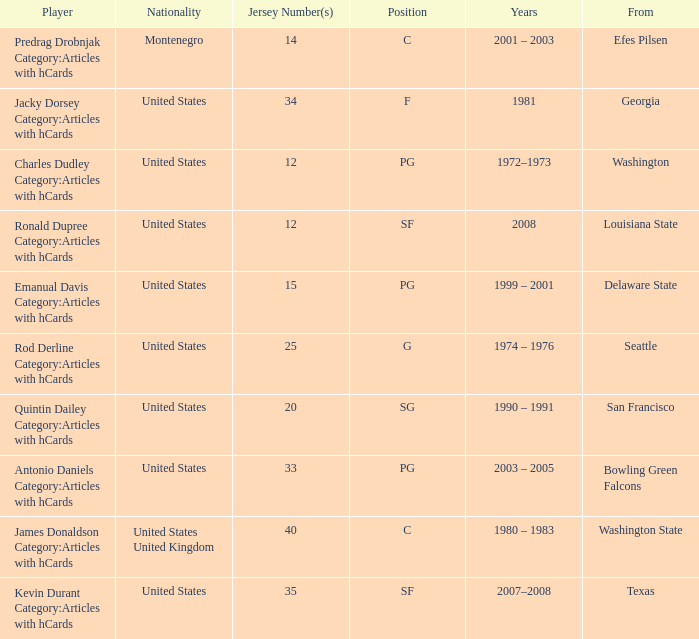From what educational institution did the participant with the 34 jersey number originate? Georgia. Would you be able to parse every entry in this table? {'header': ['Player', 'Nationality', 'Jersey Number(s)', 'Position', 'Years', 'From'], 'rows': [['Predrag Drobnjak Category:Articles with hCards', 'Montenegro', '14', 'C', '2001 – 2003', 'Efes Pilsen'], ['Jacky Dorsey Category:Articles with hCards', 'United States', '34', 'F', '1981', 'Georgia'], ['Charles Dudley Category:Articles with hCards', 'United States', '12', 'PG', '1972–1973', 'Washington'], ['Ronald Dupree Category:Articles with hCards', 'United States', '12', 'SF', '2008', 'Louisiana State'], ['Emanual Davis Category:Articles with hCards', 'United States', '15', 'PG', '1999 – 2001', 'Delaware State'], ['Rod Derline Category:Articles with hCards', 'United States', '25', 'G', '1974 – 1976', 'Seattle'], ['Quintin Dailey Category:Articles with hCards', 'United States', '20', 'SG', '1990 – 1991', 'San Francisco'], ['Antonio Daniels Category:Articles with hCards', 'United States', '33', 'PG', '2003 – 2005', 'Bowling Green Falcons'], ['James Donaldson Category:Articles with hCards', 'United States United Kingdom', '40', 'C', '1980 – 1983', 'Washington State'], ['Kevin Durant Category:Articles with hCards', 'United States', '35', 'SF', '2007–2008', 'Texas']]} 